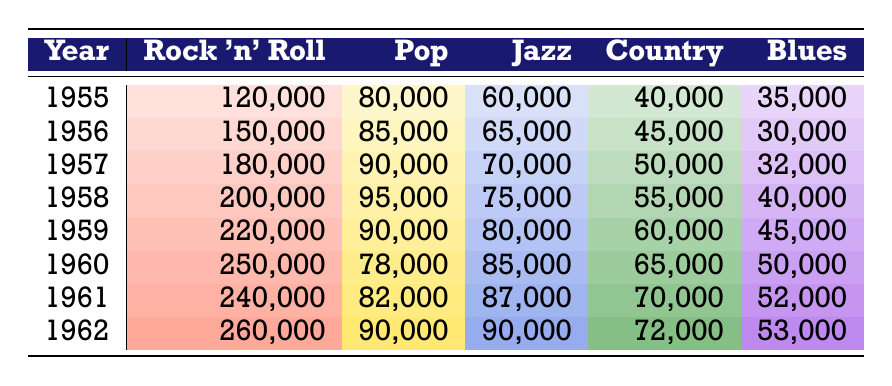What year had the highest rock and roll attendance? The highest rock and roll attendance is in 1962 with 260,000. I found this by checking the rock and roll column for the maximum number.
Answer: 1962 What was the pop attendance in 1958? The pop attendance in 1958 is 95,000. This value can be found directly in the pop column for that year.
Answer: 95,000 How many more people attended rock and roll concerts in 1960 compared to 1955? The difference in attendance is calculated as 250,000 (1960) minus 120,000 (1955), which equals 130,000.
Answer: 130,000 Is the jazz attendance in 1961 greater than that in 1962? No, the jazz attendance in 1961 is 87,000 and in 1962 it is 90,000, so 87,000 is not greater than 90,000.
Answer: No What is the total attendance for country music from 1955 to 1962? To find this total, I summed the country attendance for each year: 40,000 + 45,000 + 50,000 + 55,000 + 60,000 + 65,000 + 70,000 + 72,000 = 457,000.
Answer: 457,000 Which genre had the lowest attendance in 1956? The genre with the lowest attendance in 1956 is blues, which had 30,000. This is determined by comparing all attendance figures for that year.
Answer: Blues How many people attended jazz concerts in 1959 and 1960 combined? The total for jazz in those years is 80,000 (1959) + 85,000 (1960) = 165,000. This requires adding the two values from the respective years together.
Answer: 165,000 In which year did country music see the highest attendance relative to other genres? In 1959, country music had the highest attendance at 60,000 compared to the same year where all other genres had lower attendance numbers. This requires comparing that year's country attendance with its attendance in other years.
Answer: 1959 How did the attendance of rock and roll in 1957 compare to blues in 1960? The rock and roll attendance in 1957 is 180,000 and blues in 1960 is 50,000, so rock and roll had 130,000 more attendees than blues. This is calculated by taking 180,000 (1957) minus 50,000 (1960).
Answer: 130,000 more 